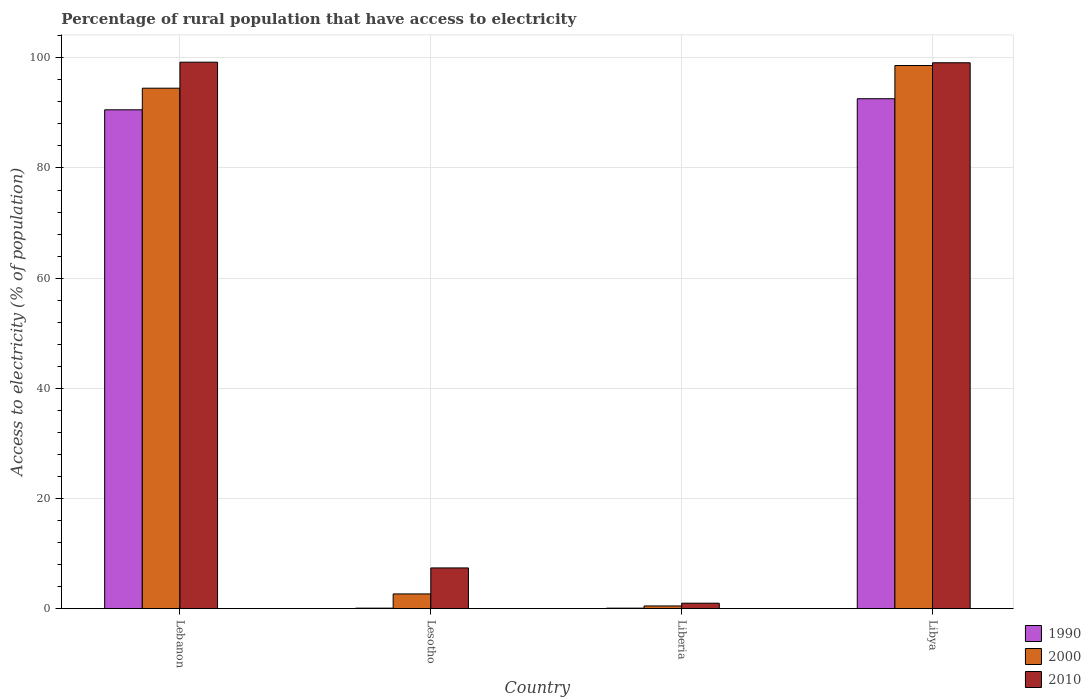How many different coloured bars are there?
Provide a short and direct response. 3. How many groups of bars are there?
Keep it short and to the point. 4. How many bars are there on the 1st tick from the right?
Ensure brevity in your answer.  3. What is the label of the 1st group of bars from the left?
Your response must be concise. Lebanon. In how many cases, is the number of bars for a given country not equal to the number of legend labels?
Give a very brief answer. 0. What is the percentage of rural population that have access to electricity in 1990 in Liberia?
Keep it short and to the point. 0.1. Across all countries, what is the maximum percentage of rural population that have access to electricity in 2000?
Offer a very short reply. 98.6. In which country was the percentage of rural population that have access to electricity in 2010 maximum?
Provide a succinct answer. Lebanon. In which country was the percentage of rural population that have access to electricity in 2010 minimum?
Provide a short and direct response. Liberia. What is the total percentage of rural population that have access to electricity in 2000 in the graph?
Make the answer very short. 196.26. What is the difference between the percentage of rural population that have access to electricity in 2010 in Liberia and that in Libya?
Your answer should be compact. -98.1. What is the difference between the percentage of rural population that have access to electricity in 1990 in Liberia and the percentage of rural population that have access to electricity in 2000 in Lesotho?
Your answer should be compact. -2.58. What is the average percentage of rural population that have access to electricity in 1990 per country?
Keep it short and to the point. 45.83. What is the difference between the percentage of rural population that have access to electricity of/in 2010 and percentage of rural population that have access to electricity of/in 1990 in Lebanon?
Your answer should be compact. 8.64. What is the ratio of the percentage of rural population that have access to electricity in 1990 in Lebanon to that in Lesotho?
Your response must be concise. 905.6. Is the percentage of rural population that have access to electricity in 2010 in Liberia less than that in Libya?
Your response must be concise. Yes. Is the difference between the percentage of rural population that have access to electricity in 2010 in Lebanon and Lesotho greater than the difference between the percentage of rural population that have access to electricity in 1990 in Lebanon and Lesotho?
Keep it short and to the point. Yes. What is the difference between the highest and the second highest percentage of rural population that have access to electricity in 2010?
Keep it short and to the point. -0.1. What is the difference between the highest and the lowest percentage of rural population that have access to electricity in 2000?
Offer a terse response. 98.1. Is the sum of the percentage of rural population that have access to electricity in 2010 in Lebanon and Libya greater than the maximum percentage of rural population that have access to electricity in 1990 across all countries?
Your answer should be very brief. Yes. What does the 1st bar from the right in Liberia represents?
Your answer should be very brief. 2010. Is it the case that in every country, the sum of the percentage of rural population that have access to electricity in 2000 and percentage of rural population that have access to electricity in 1990 is greater than the percentage of rural population that have access to electricity in 2010?
Your answer should be compact. No. Are all the bars in the graph horizontal?
Ensure brevity in your answer.  No. Does the graph contain grids?
Make the answer very short. Yes. Where does the legend appear in the graph?
Your answer should be very brief. Bottom right. How are the legend labels stacked?
Offer a terse response. Vertical. What is the title of the graph?
Your answer should be very brief. Percentage of rural population that have access to electricity. What is the label or title of the Y-axis?
Your answer should be very brief. Access to electricity (% of population). What is the Access to electricity (% of population) of 1990 in Lebanon?
Provide a short and direct response. 90.56. What is the Access to electricity (% of population) in 2000 in Lebanon?
Your answer should be very brief. 94.48. What is the Access to electricity (% of population) of 2010 in Lebanon?
Your answer should be compact. 99.2. What is the Access to electricity (% of population) in 1990 in Lesotho?
Ensure brevity in your answer.  0.1. What is the Access to electricity (% of population) in 2000 in Lesotho?
Your answer should be compact. 2.68. What is the Access to electricity (% of population) in 2010 in Lesotho?
Make the answer very short. 7.4. What is the Access to electricity (% of population) of 1990 in Libya?
Provide a succinct answer. 92.57. What is the Access to electricity (% of population) in 2000 in Libya?
Provide a short and direct response. 98.6. What is the Access to electricity (% of population) of 2010 in Libya?
Your response must be concise. 99.1. Across all countries, what is the maximum Access to electricity (% of population) of 1990?
Provide a succinct answer. 92.57. Across all countries, what is the maximum Access to electricity (% of population) of 2000?
Keep it short and to the point. 98.6. Across all countries, what is the maximum Access to electricity (% of population) in 2010?
Ensure brevity in your answer.  99.2. Across all countries, what is the minimum Access to electricity (% of population) in 2000?
Ensure brevity in your answer.  0.5. Across all countries, what is the minimum Access to electricity (% of population) in 2010?
Give a very brief answer. 1. What is the total Access to electricity (% of population) in 1990 in the graph?
Give a very brief answer. 183.33. What is the total Access to electricity (% of population) in 2000 in the graph?
Ensure brevity in your answer.  196.26. What is the total Access to electricity (% of population) of 2010 in the graph?
Offer a terse response. 206.7. What is the difference between the Access to electricity (% of population) in 1990 in Lebanon and that in Lesotho?
Your answer should be compact. 90.46. What is the difference between the Access to electricity (% of population) in 2000 in Lebanon and that in Lesotho?
Make the answer very short. 91.8. What is the difference between the Access to electricity (% of population) in 2010 in Lebanon and that in Lesotho?
Ensure brevity in your answer.  91.8. What is the difference between the Access to electricity (% of population) in 1990 in Lebanon and that in Liberia?
Your answer should be very brief. 90.46. What is the difference between the Access to electricity (% of population) in 2000 in Lebanon and that in Liberia?
Provide a short and direct response. 93.98. What is the difference between the Access to electricity (% of population) in 2010 in Lebanon and that in Liberia?
Your answer should be very brief. 98.2. What is the difference between the Access to electricity (% of population) in 1990 in Lebanon and that in Libya?
Ensure brevity in your answer.  -2.01. What is the difference between the Access to electricity (% of population) in 2000 in Lebanon and that in Libya?
Offer a very short reply. -4.12. What is the difference between the Access to electricity (% of population) of 2010 in Lebanon and that in Libya?
Keep it short and to the point. 0.1. What is the difference between the Access to electricity (% of population) in 2000 in Lesotho and that in Liberia?
Give a very brief answer. 2.18. What is the difference between the Access to electricity (% of population) in 2010 in Lesotho and that in Liberia?
Keep it short and to the point. 6.4. What is the difference between the Access to electricity (% of population) in 1990 in Lesotho and that in Libya?
Your answer should be compact. -92.47. What is the difference between the Access to electricity (% of population) in 2000 in Lesotho and that in Libya?
Your response must be concise. -95.92. What is the difference between the Access to electricity (% of population) of 2010 in Lesotho and that in Libya?
Your answer should be very brief. -91.7. What is the difference between the Access to electricity (% of population) of 1990 in Liberia and that in Libya?
Offer a terse response. -92.47. What is the difference between the Access to electricity (% of population) of 2000 in Liberia and that in Libya?
Your response must be concise. -98.1. What is the difference between the Access to electricity (% of population) in 2010 in Liberia and that in Libya?
Your answer should be compact. -98.1. What is the difference between the Access to electricity (% of population) of 1990 in Lebanon and the Access to electricity (% of population) of 2000 in Lesotho?
Your response must be concise. 87.88. What is the difference between the Access to electricity (% of population) of 1990 in Lebanon and the Access to electricity (% of population) of 2010 in Lesotho?
Keep it short and to the point. 83.16. What is the difference between the Access to electricity (% of population) in 2000 in Lebanon and the Access to electricity (% of population) in 2010 in Lesotho?
Ensure brevity in your answer.  87.08. What is the difference between the Access to electricity (% of population) in 1990 in Lebanon and the Access to electricity (% of population) in 2000 in Liberia?
Keep it short and to the point. 90.06. What is the difference between the Access to electricity (% of population) of 1990 in Lebanon and the Access to electricity (% of population) of 2010 in Liberia?
Provide a succinct answer. 89.56. What is the difference between the Access to electricity (% of population) of 2000 in Lebanon and the Access to electricity (% of population) of 2010 in Liberia?
Give a very brief answer. 93.48. What is the difference between the Access to electricity (% of population) in 1990 in Lebanon and the Access to electricity (% of population) in 2000 in Libya?
Provide a succinct answer. -8.04. What is the difference between the Access to electricity (% of population) in 1990 in Lebanon and the Access to electricity (% of population) in 2010 in Libya?
Your answer should be compact. -8.54. What is the difference between the Access to electricity (% of population) in 2000 in Lebanon and the Access to electricity (% of population) in 2010 in Libya?
Make the answer very short. -4.62. What is the difference between the Access to electricity (% of population) of 2000 in Lesotho and the Access to electricity (% of population) of 2010 in Liberia?
Make the answer very short. 1.68. What is the difference between the Access to electricity (% of population) of 1990 in Lesotho and the Access to electricity (% of population) of 2000 in Libya?
Your answer should be very brief. -98.5. What is the difference between the Access to electricity (% of population) in 1990 in Lesotho and the Access to electricity (% of population) in 2010 in Libya?
Offer a terse response. -99. What is the difference between the Access to electricity (% of population) of 2000 in Lesotho and the Access to electricity (% of population) of 2010 in Libya?
Your answer should be compact. -96.42. What is the difference between the Access to electricity (% of population) of 1990 in Liberia and the Access to electricity (% of population) of 2000 in Libya?
Your response must be concise. -98.5. What is the difference between the Access to electricity (% of population) of 1990 in Liberia and the Access to electricity (% of population) of 2010 in Libya?
Offer a very short reply. -99. What is the difference between the Access to electricity (% of population) of 2000 in Liberia and the Access to electricity (% of population) of 2010 in Libya?
Ensure brevity in your answer.  -98.6. What is the average Access to electricity (% of population) of 1990 per country?
Offer a terse response. 45.83. What is the average Access to electricity (% of population) of 2000 per country?
Your answer should be compact. 49.07. What is the average Access to electricity (% of population) of 2010 per country?
Provide a succinct answer. 51.67. What is the difference between the Access to electricity (% of population) of 1990 and Access to electricity (% of population) of 2000 in Lebanon?
Make the answer very short. -3.92. What is the difference between the Access to electricity (% of population) of 1990 and Access to electricity (% of population) of 2010 in Lebanon?
Your answer should be compact. -8.64. What is the difference between the Access to electricity (% of population) of 2000 and Access to electricity (% of population) of 2010 in Lebanon?
Offer a terse response. -4.72. What is the difference between the Access to electricity (% of population) in 1990 and Access to electricity (% of population) in 2000 in Lesotho?
Keep it short and to the point. -2.58. What is the difference between the Access to electricity (% of population) of 1990 and Access to electricity (% of population) of 2010 in Lesotho?
Provide a succinct answer. -7.3. What is the difference between the Access to electricity (% of population) in 2000 and Access to electricity (% of population) in 2010 in Lesotho?
Give a very brief answer. -4.72. What is the difference between the Access to electricity (% of population) of 1990 and Access to electricity (% of population) of 2010 in Liberia?
Offer a terse response. -0.9. What is the difference between the Access to electricity (% of population) in 2000 and Access to electricity (% of population) in 2010 in Liberia?
Keep it short and to the point. -0.5. What is the difference between the Access to electricity (% of population) of 1990 and Access to electricity (% of population) of 2000 in Libya?
Keep it short and to the point. -6.03. What is the difference between the Access to electricity (% of population) in 1990 and Access to electricity (% of population) in 2010 in Libya?
Provide a succinct answer. -6.53. What is the ratio of the Access to electricity (% of population) of 1990 in Lebanon to that in Lesotho?
Make the answer very short. 905.6. What is the ratio of the Access to electricity (% of population) of 2000 in Lebanon to that in Lesotho?
Your answer should be compact. 35.25. What is the ratio of the Access to electricity (% of population) in 2010 in Lebanon to that in Lesotho?
Provide a short and direct response. 13.41. What is the ratio of the Access to electricity (% of population) in 1990 in Lebanon to that in Liberia?
Offer a very short reply. 905.6. What is the ratio of the Access to electricity (% of population) of 2000 in Lebanon to that in Liberia?
Provide a short and direct response. 188.96. What is the ratio of the Access to electricity (% of population) of 2010 in Lebanon to that in Liberia?
Offer a very short reply. 99.2. What is the ratio of the Access to electricity (% of population) of 1990 in Lebanon to that in Libya?
Offer a terse response. 0.98. What is the ratio of the Access to electricity (% of population) in 2000 in Lebanon to that in Libya?
Your answer should be very brief. 0.96. What is the ratio of the Access to electricity (% of population) in 2010 in Lebanon to that in Libya?
Your answer should be very brief. 1. What is the ratio of the Access to electricity (% of population) in 1990 in Lesotho to that in Liberia?
Offer a very short reply. 1. What is the ratio of the Access to electricity (% of population) of 2000 in Lesotho to that in Liberia?
Offer a very short reply. 5.36. What is the ratio of the Access to electricity (% of population) of 1990 in Lesotho to that in Libya?
Provide a short and direct response. 0. What is the ratio of the Access to electricity (% of population) in 2000 in Lesotho to that in Libya?
Keep it short and to the point. 0.03. What is the ratio of the Access to electricity (% of population) in 2010 in Lesotho to that in Libya?
Keep it short and to the point. 0.07. What is the ratio of the Access to electricity (% of population) in 1990 in Liberia to that in Libya?
Offer a very short reply. 0. What is the ratio of the Access to electricity (% of population) in 2000 in Liberia to that in Libya?
Keep it short and to the point. 0.01. What is the ratio of the Access to electricity (% of population) of 2010 in Liberia to that in Libya?
Your answer should be compact. 0.01. What is the difference between the highest and the second highest Access to electricity (% of population) in 1990?
Your answer should be very brief. 2.01. What is the difference between the highest and the second highest Access to electricity (% of population) of 2000?
Provide a short and direct response. 4.12. What is the difference between the highest and the lowest Access to electricity (% of population) of 1990?
Offer a terse response. 92.47. What is the difference between the highest and the lowest Access to electricity (% of population) of 2000?
Offer a terse response. 98.1. What is the difference between the highest and the lowest Access to electricity (% of population) in 2010?
Offer a terse response. 98.2. 